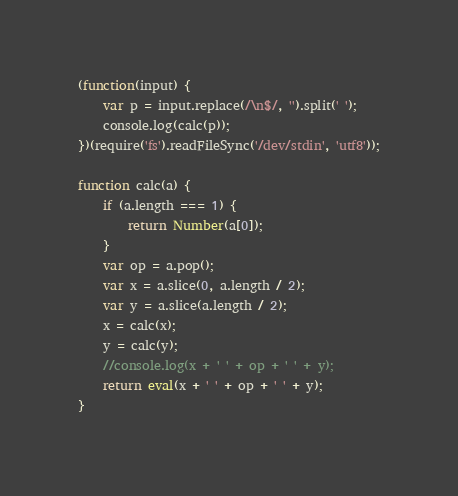<code> <loc_0><loc_0><loc_500><loc_500><_JavaScript_>(function(input) {
    var p = input.replace(/\n$/, '').split(' ');
    console.log(calc(p));
})(require('fs').readFileSync('/dev/stdin', 'utf8'));

function calc(a) {
    if (a.length === 1) {
        return Number(a[0]);
    }
    var op = a.pop();
    var x = a.slice(0, a.length / 2);
    var y = a.slice(a.length / 2);
    x = calc(x);
    y = calc(y);
    //console.log(x + ' ' + op + ' ' + y);
    return eval(x + ' ' + op + ' ' + y);
}</code> 